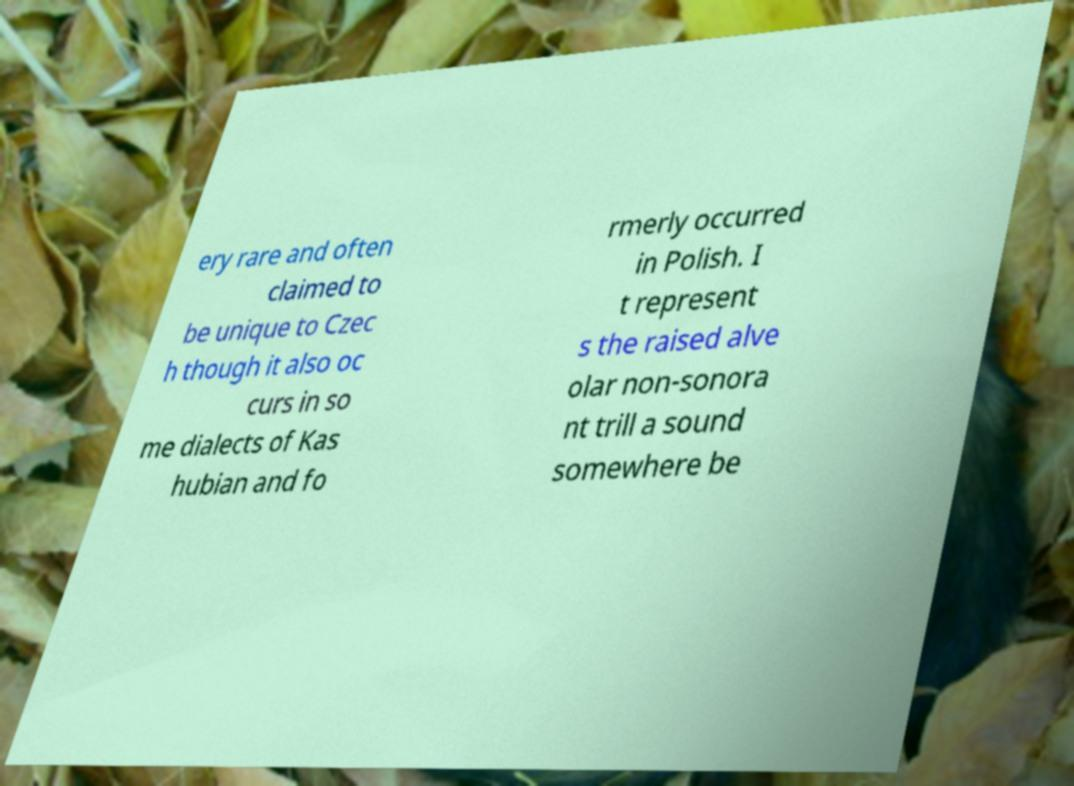Please identify and transcribe the text found in this image. ery rare and often claimed to be unique to Czec h though it also oc curs in so me dialects of Kas hubian and fo rmerly occurred in Polish. I t represent s the raised alve olar non-sonora nt trill a sound somewhere be 